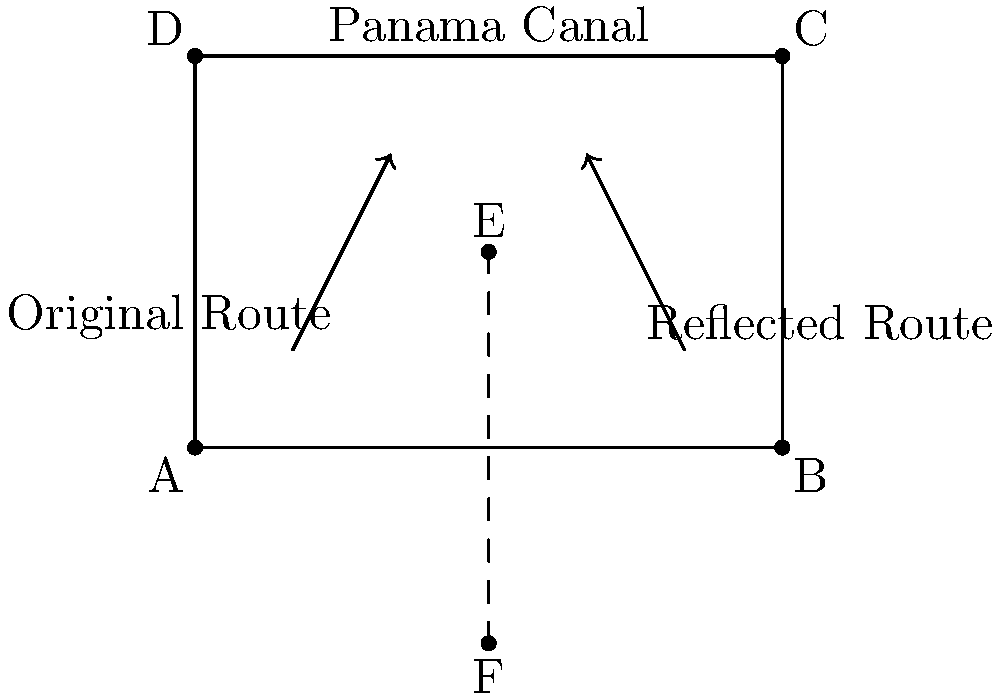A cargo ship needs to travel from point A to point C across the Panama Canal. The captain wants to determine the most efficient route by reflecting the original path across the canal's centerline. If the original route is represented by the line segment AE, what are the coordinates of point F, which represents the endpoint of the reflected route? To solve this problem, we'll use the properties of reflection across a line:

1. The canal's centerline is represented by the line $x = 3$.

2. The coordinates of the given points are:
   A(0,0), C(6,4), and E(3,2)

3. To reflect point E across the line $x = 3$, we use the formula:
   $x_{reflected} = 2(3) - x_{original} = 6 - x_{original}$

4. For point E(3,2):
   $x_{reflected} = 6 - 3 = 3$
   $y_{reflected} = y_{original} = 2$

5. So, the reflected point E is (3,2), which is the same as the original point E. This is because E is on the line of reflection.

6. To find F, we need to reflect A(0,0):
   $x_{reflected} = 6 - 0 = 6$
   $y_{reflected} = 0$

Therefore, the coordinates of point F are (6,0).
Answer: (6,0) 